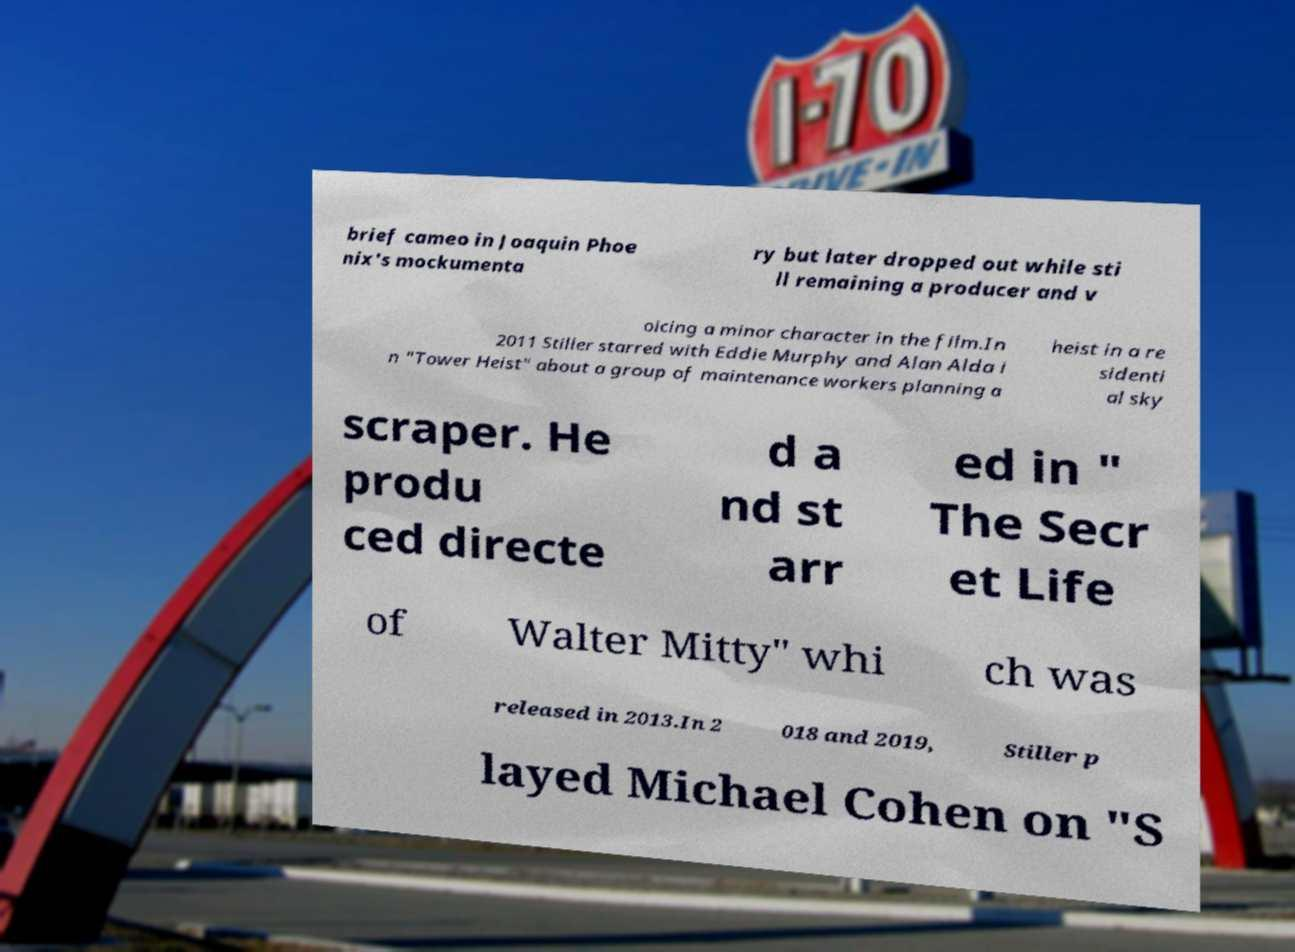What messages or text are displayed in this image? I need them in a readable, typed format. brief cameo in Joaquin Phoe nix's mockumenta ry but later dropped out while sti ll remaining a producer and v oicing a minor character in the film.In 2011 Stiller starred with Eddie Murphy and Alan Alda i n "Tower Heist" about a group of maintenance workers planning a heist in a re sidenti al sky scraper. He produ ced directe d a nd st arr ed in " The Secr et Life of Walter Mitty" whi ch was released in 2013.In 2 018 and 2019, Stiller p layed Michael Cohen on "S 